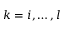Convert formula to latex. <formula><loc_0><loc_0><loc_500><loc_500>k = i , \dots , l</formula> 